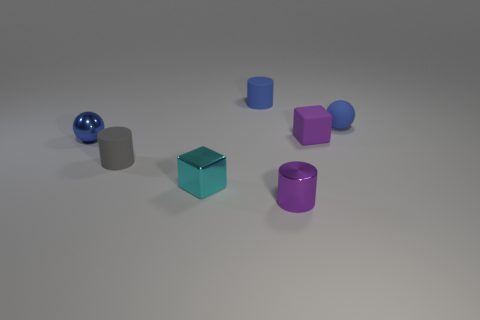Subtract all tiny matte cylinders. How many cylinders are left? 1 Subtract all purple cylinders. How many cylinders are left? 2 Add 1 gray rubber objects. How many objects exist? 8 Subtract all cubes. How many objects are left? 5 Subtract all blue blocks. How many green balls are left? 0 Subtract 1 cylinders. How many cylinders are left? 2 Subtract all brown blocks. Subtract all green cylinders. How many blocks are left? 2 Subtract all small brown metallic spheres. Subtract all cyan objects. How many objects are left? 6 Add 3 blue matte objects. How many blue matte objects are left? 5 Add 4 tiny metal spheres. How many tiny metal spheres exist? 5 